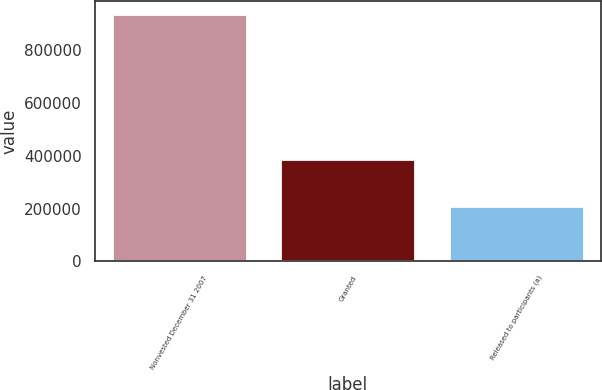Convert chart to OTSL. <chart><loc_0><loc_0><loc_500><loc_500><bar_chart><fcel>Nonvested December 31 2007<fcel>Granted<fcel>Released to participants (a)<nl><fcel>936916<fcel>387125<fcel>211517<nl></chart> 